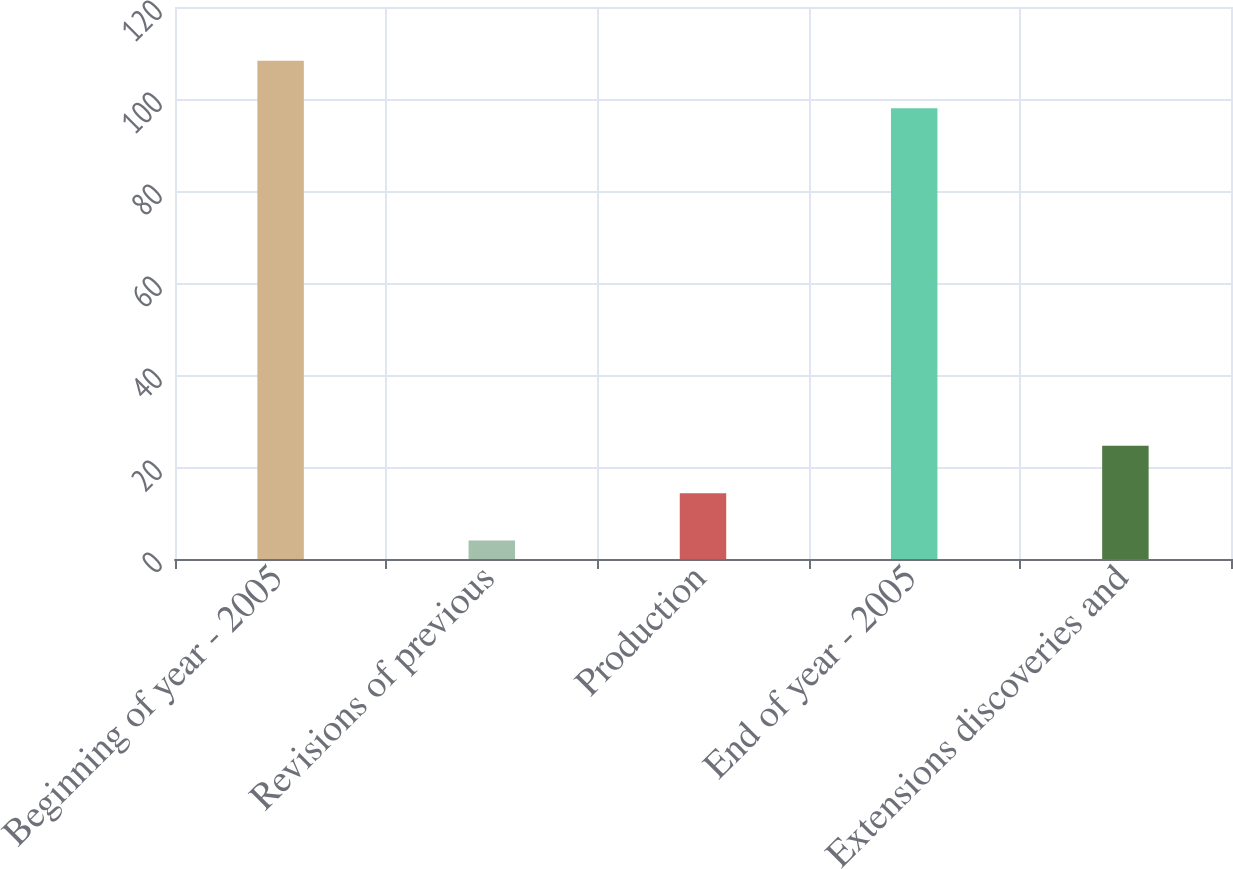Convert chart to OTSL. <chart><loc_0><loc_0><loc_500><loc_500><bar_chart><fcel>Beginning of year - 2005<fcel>Revisions of previous<fcel>Production<fcel>End of year - 2005<fcel>Extensions discoveries and<nl><fcel>108.3<fcel>4<fcel>14.3<fcel>98<fcel>24.6<nl></chart> 